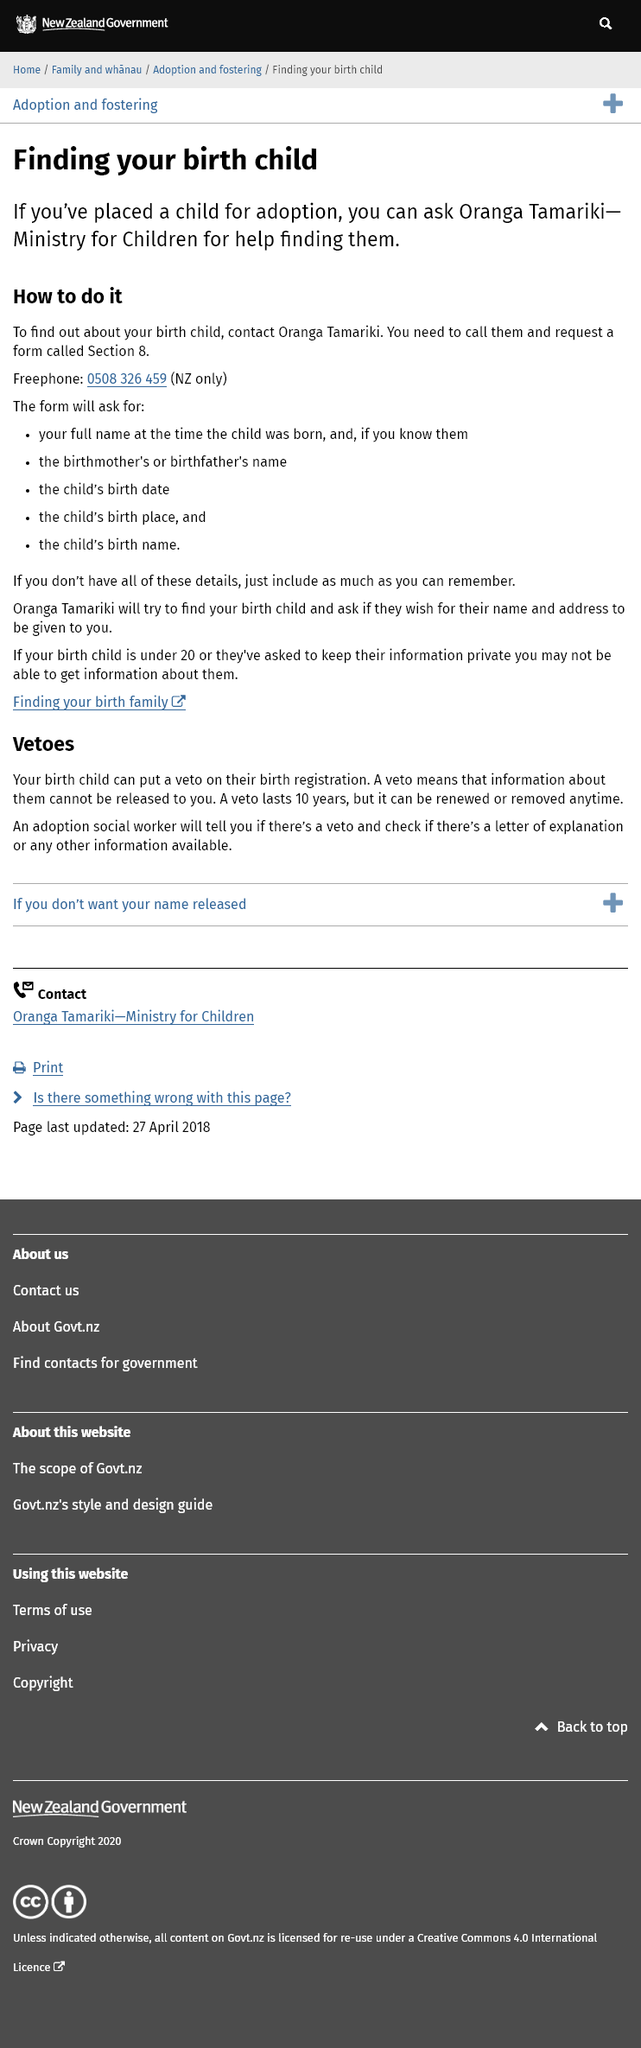Point out several critical features in this image. You need to call 0508 326 459 to request a Section 8 form. It is the responsibility of an adoption social worker to inform the parent(s) if there is a veto by the birth child on their birth registration. You can contact Oranga Tamariki - Ministry for Children for help in finding a child that you have put up for adoption. 